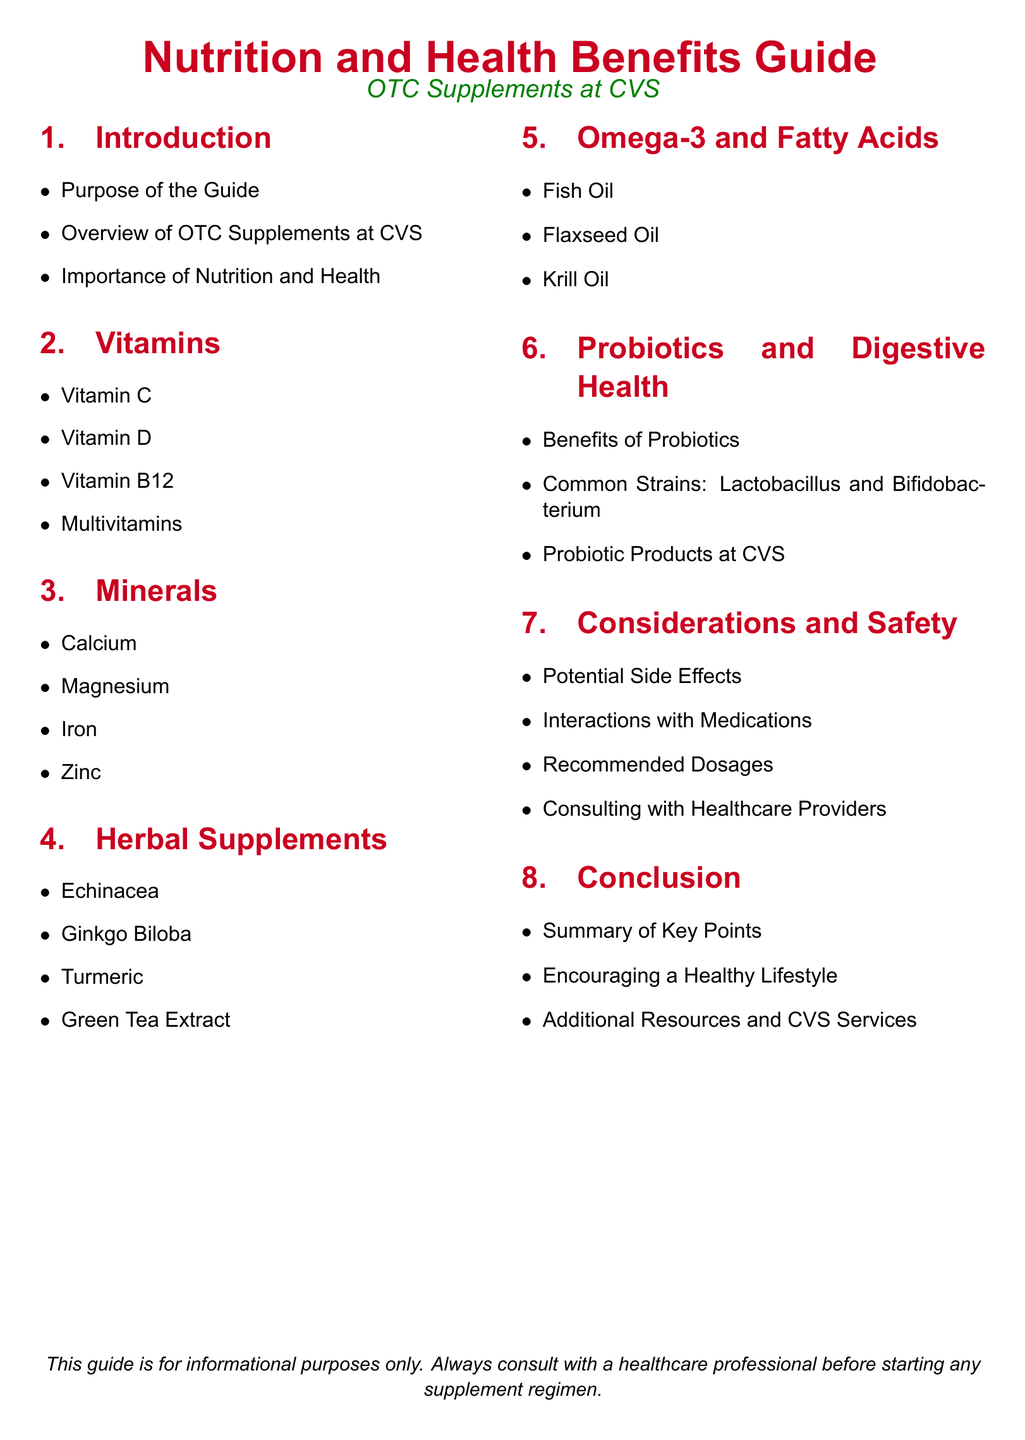What is the purpose of the guide? The purpose of the guide is outlined in the Introduction section and indicates that it serves as a resource for understanding nutrition and health benefits of OTC supplements.
Answer: Purpose of the Guide What vitamin is associated with immune support? Vitamin C is known for its role in supporting the immune system, mentioned under the Vitamins section.
Answer: Vitamin C Which mineral is important for bone health? Calcium is specifically noted for its importance in bone health in the Minerals section.
Answer: Calcium List one common probiotic strain. The document mentions Lactobacillus and Bifidobacterium as common strains in the Probiotics and Digestive Health section.
Answer: Lactobacillus What should you do before starting any supplement regimen? The guide advises consulting with a healthcare professional before beginning any supplements in the Considerations and Safety section.
Answer: Consulting with Healthcare Providers How many types of herbal supplements are mentioned? There are four herbal supplements listed in the document under the Herbal Supplements section.
Answer: Four What is highlighted in the conclusion section? The conclusion summarizes key points, encourages a healthy lifestyle, and mentions additional resources, detailing the overall purpose of the guide.
Answer: Summary of Key Points What type of supplements are Omega-3 and Fatty Acids categorized under? The guide lists Fish Oil, Flaxseed Oil, and Krill Oil under Omega-3 and Fatty Acids.
Answer: Omega-3 and Fatty Acids What potential issue is mentioned in the Considerations and Safety section? Potential side effects are discussed as a consideration when using supplements, indicating a need for caution.
Answer: Potential Side Effects 